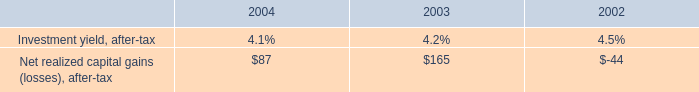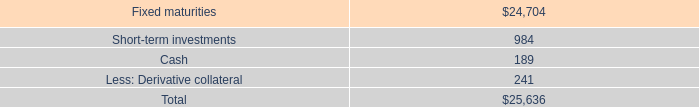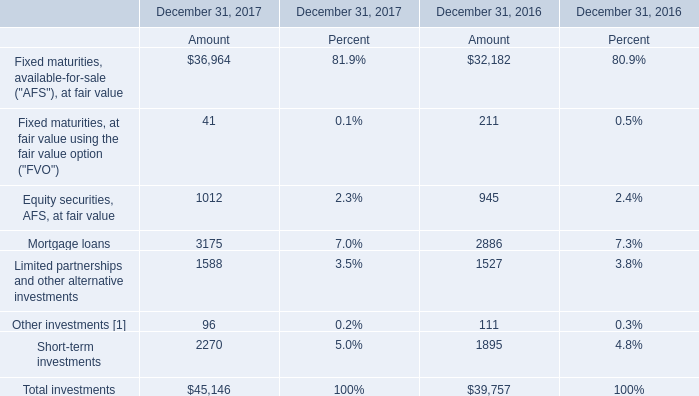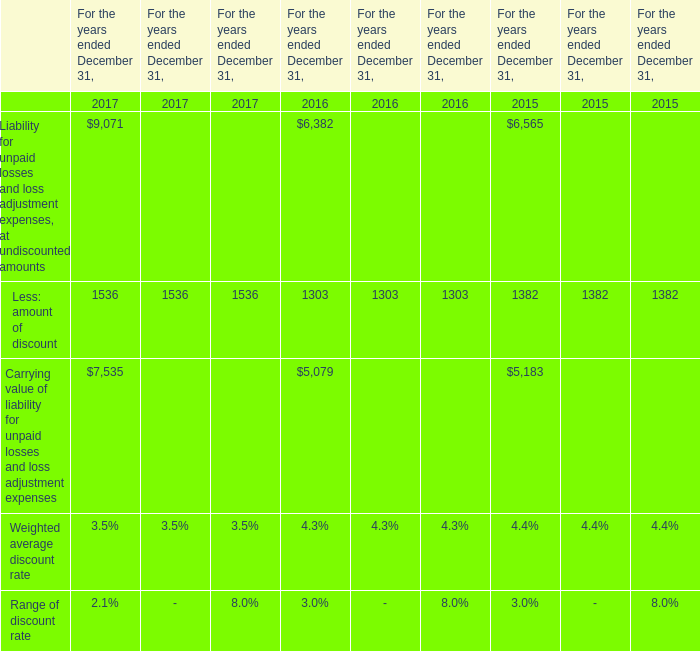What's the average of the Less: amount of discount in the years where Equity securities, AFS, at fair value for Amount is positive? 
Computations: (((1536 + 1303) + 1382) / 3)
Answer: 1407.0. 